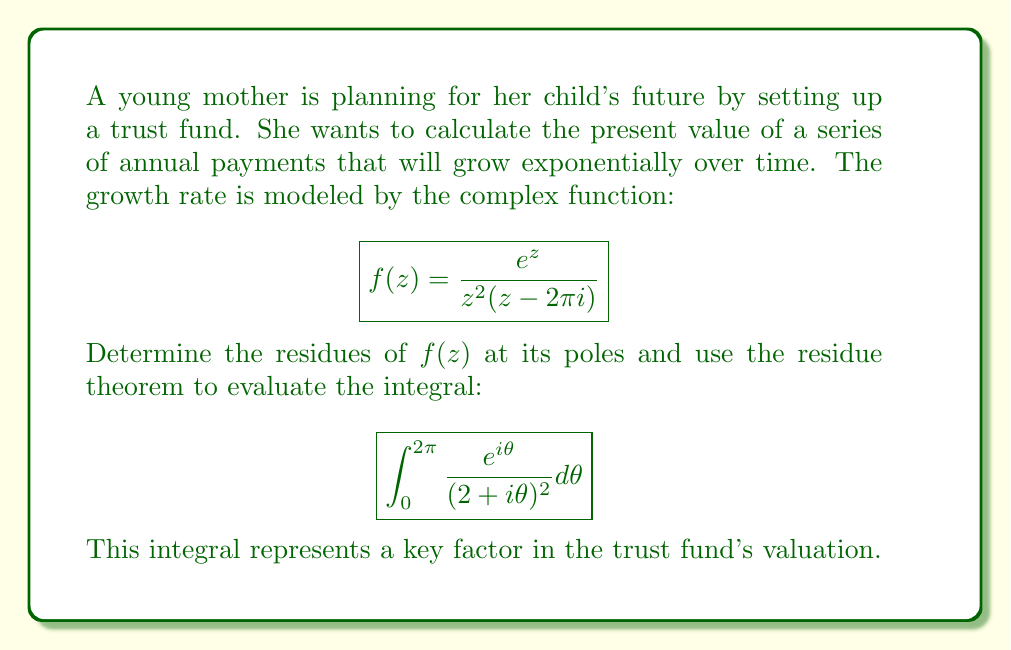Solve this math problem. Let's approach this step-by-step:

1) First, we need to identify the poles of $f(z)$:
   - $z = 0$ (double pole)
   - $z = 2\pi i$ (simple pole)

2) For the residue at $z = 0$:
   We use the formula for a double pole: $Res(f,0) = \lim_{z\to 0} \frac{d}{dz}[z^2f(z)]$
   
   $$\begin{align}
   Res(f,0) &= \lim_{z\to 0} \frac{d}{dz}[\frac{e^z}{z-2\pi i}] \\
   &= \lim_{z\to 0} \frac{e^z(z-2\pi i) - e^z}{(z-2\pi i)^2} \\
   &= \frac{1}{(2\pi i)^2} = -\frac{1}{4\pi^2}
   \end{align}$$

3) For the residue at $z = 2\pi i$:
   We use the formula for a simple pole: $Res(f,2\pi i) = \lim_{z\to 2\pi i} (z-2\pi i)f(z)$
   
   $$\begin{align}
   Res(f,2\pi i) &= \lim_{z\to 2\pi i} \frac{e^z}{z^2} \\
   &= \frac{e^{2\pi i}}{(2\pi i)^2} = -\frac{1}{4\pi^2}
   \end{align}$$

4) Now, for the integral:
   $$\int_0^{2\pi} \frac{e^{i\theta}}{(2+i\theta)^2} d\theta$$
   
   Let $z = 2+i\theta$, then $dz = id\theta$ and when $\theta$ goes from 0 to $2\pi$, $z$ describes a circle with radius 2 centered at 2.
   
   The integral becomes:
   $$\oint_{|z-2|=2} \frac{e^{i(\frac{z-2}{i})}}{z^2} \frac{dz}{i}$$

5) By the residue theorem:
   $$\oint_{|z-2|=2} \frac{e^{i(\frac{z-2}{i})}}{z^2} \frac{dz}{i} = 2\pi i \cdot Res(f,0)$$

6) Therefore:
   $$\int_0^{2\pi} \frac{e^{i\theta}}{(2+i\theta)^2} d\theta = 2\pi i \cdot (-\frac{1}{4\pi^2}) = -\frac{i}{2\pi}$$
Answer: $-\frac{i}{2\pi}$ 